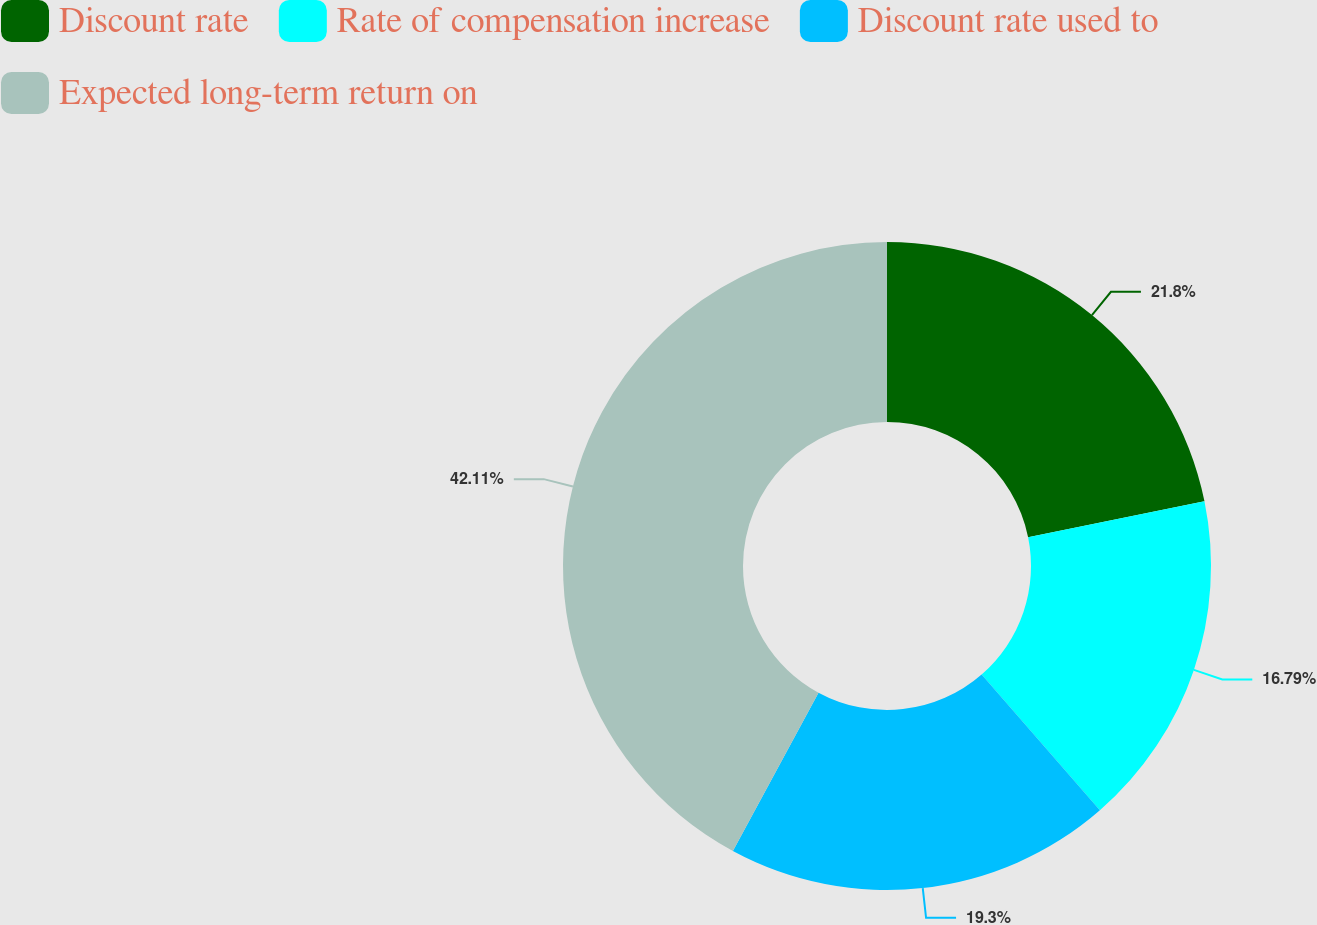Convert chart to OTSL. <chart><loc_0><loc_0><loc_500><loc_500><pie_chart><fcel>Discount rate<fcel>Rate of compensation increase<fcel>Discount rate used to<fcel>Expected long-term return on<nl><fcel>21.8%<fcel>16.79%<fcel>19.3%<fcel>42.11%<nl></chart> 